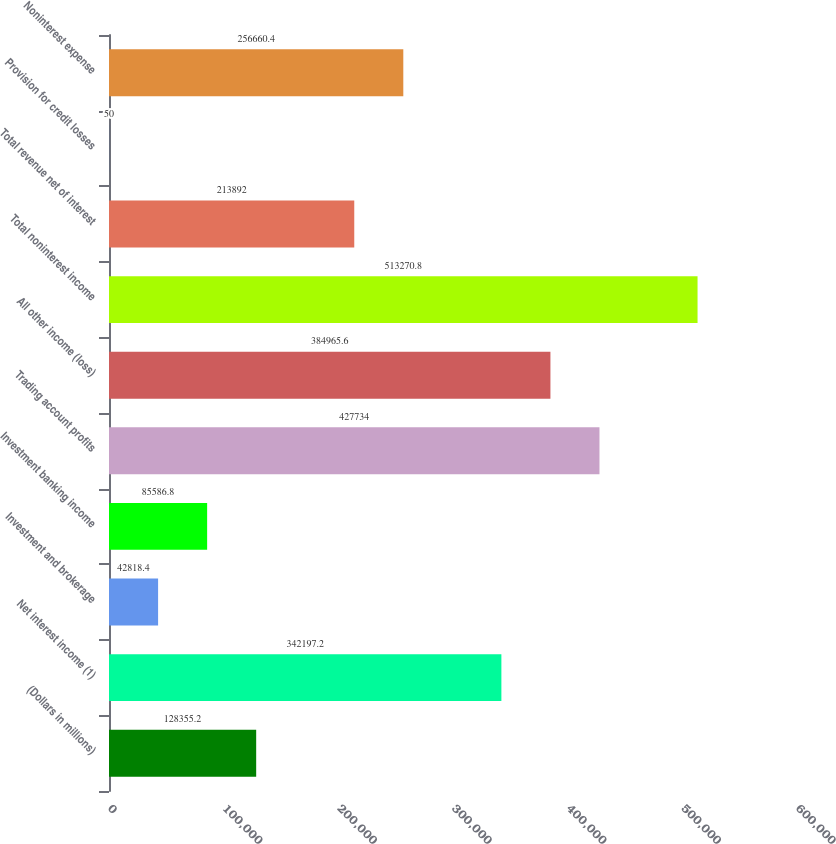Convert chart to OTSL. <chart><loc_0><loc_0><loc_500><loc_500><bar_chart><fcel>(Dollars in millions)<fcel>Net interest income (1)<fcel>Investment and brokerage<fcel>Investment banking income<fcel>Trading account profits<fcel>All other income (loss)<fcel>Total noninterest income<fcel>Total revenue net of interest<fcel>Provision for credit losses<fcel>Noninterest expense<nl><fcel>128355<fcel>342197<fcel>42818.4<fcel>85586.8<fcel>427734<fcel>384966<fcel>513271<fcel>213892<fcel>50<fcel>256660<nl></chart> 